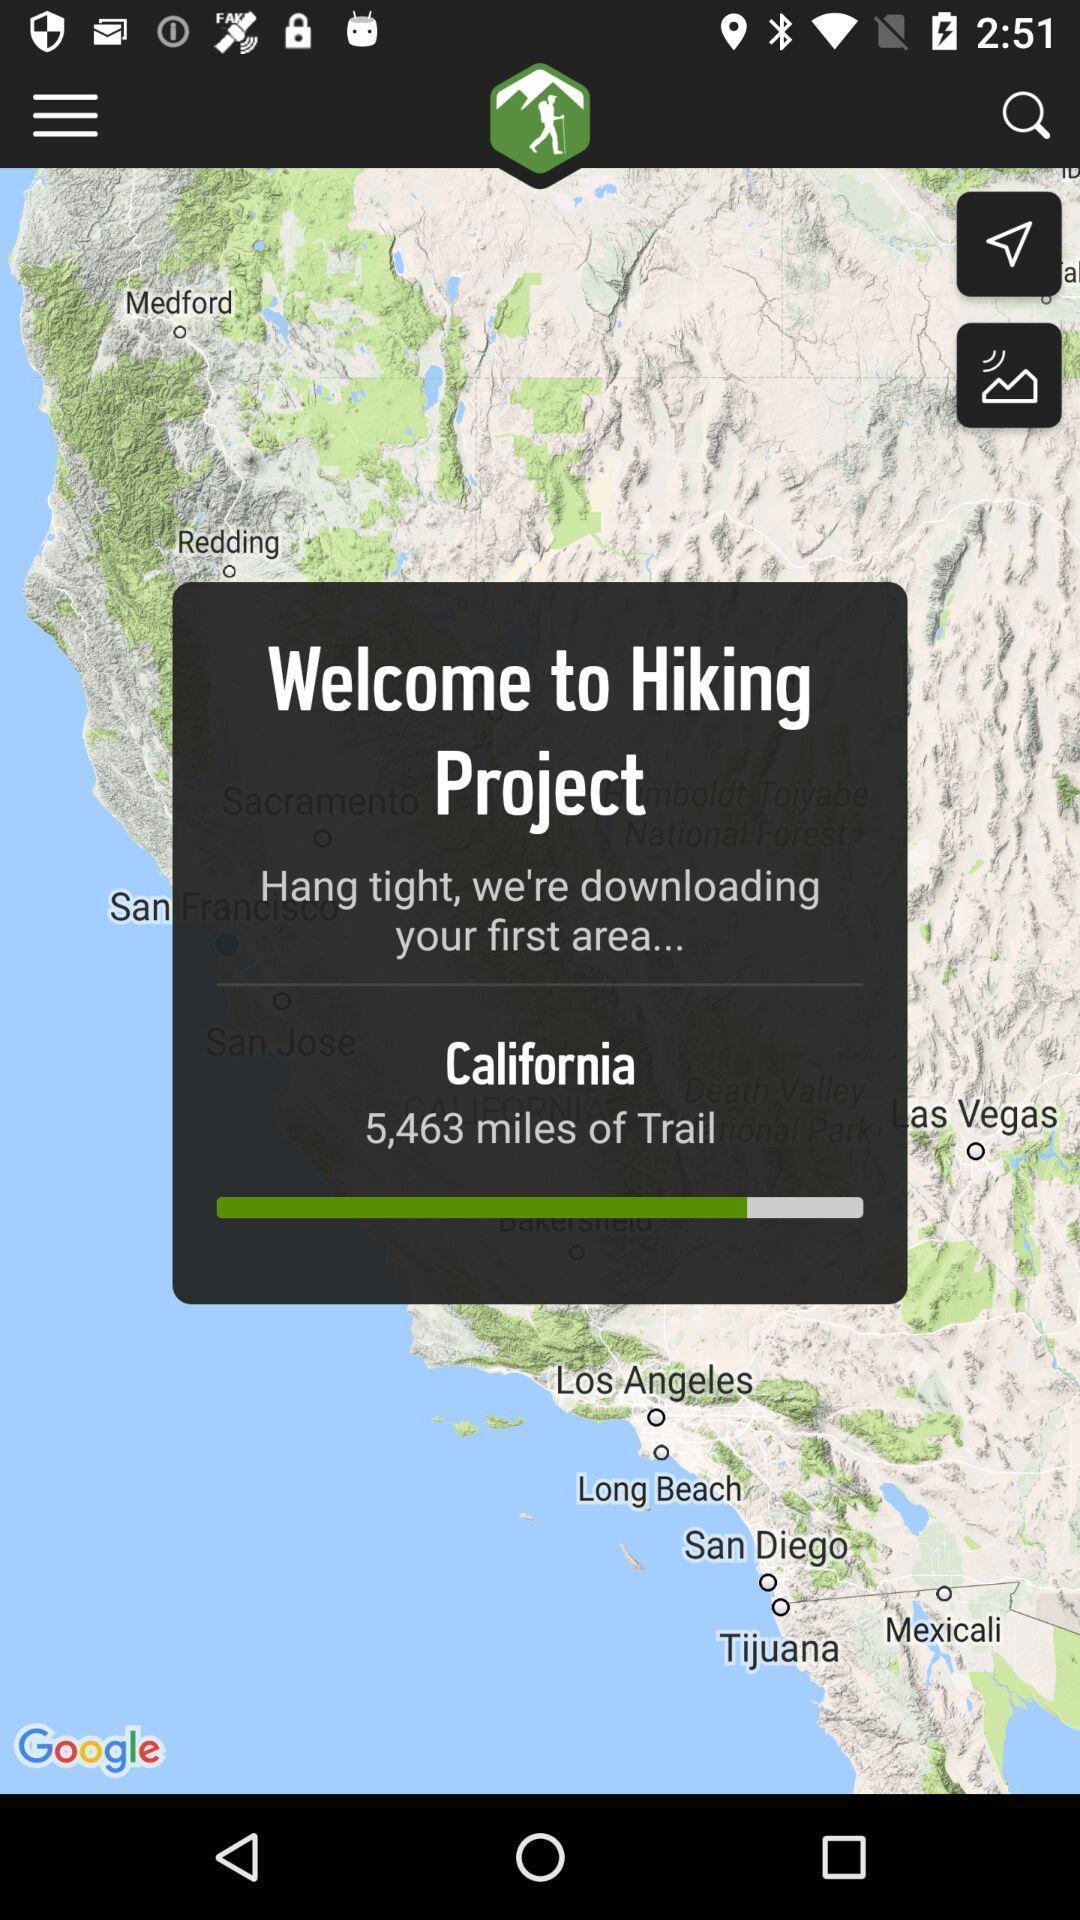What details can you identify in this image? Welcome page of a hiking project. 